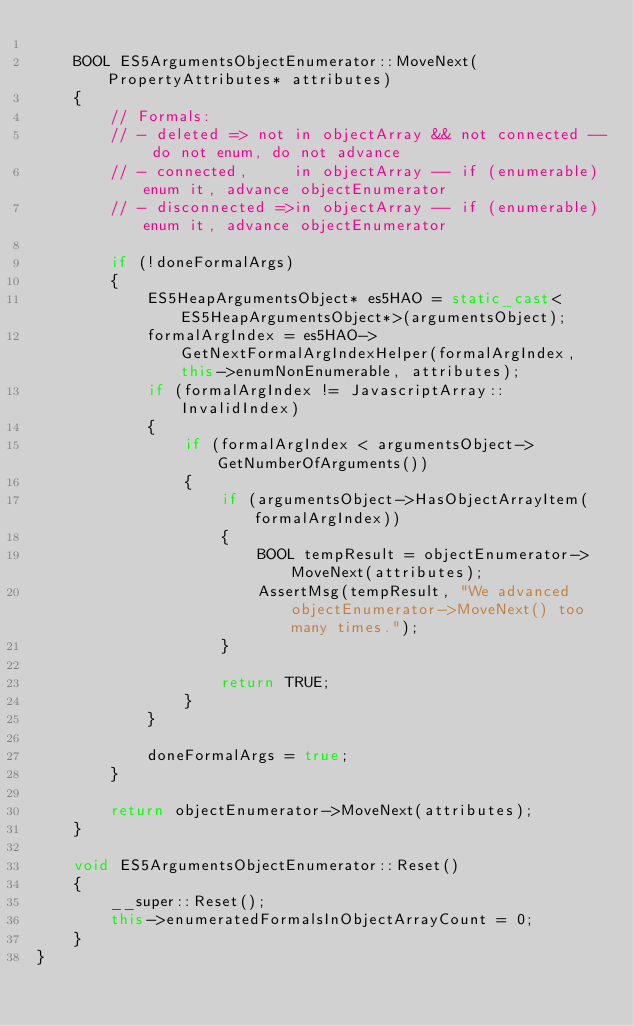Convert code to text. <code><loc_0><loc_0><loc_500><loc_500><_C++_>
    BOOL ES5ArgumentsObjectEnumerator::MoveNext(PropertyAttributes* attributes)
    {
        // Formals:
        // - deleted => not in objectArray && not connected -- do not enum, do not advance
        // - connected,     in objectArray -- if (enumerable) enum it, advance objectEnumerator
        // - disconnected =>in objectArray -- if (enumerable) enum it, advance objectEnumerator

        if (!doneFormalArgs)
        {
            ES5HeapArgumentsObject* es5HAO = static_cast<ES5HeapArgumentsObject*>(argumentsObject);
            formalArgIndex = es5HAO->GetNextFormalArgIndexHelper(formalArgIndex, this->enumNonEnumerable, attributes);
            if (formalArgIndex != JavascriptArray::InvalidIndex)
            {
                if (formalArgIndex < argumentsObject->GetNumberOfArguments())
                {
                    if (argumentsObject->HasObjectArrayItem(formalArgIndex))
                    {
                        BOOL tempResult = objectEnumerator->MoveNext(attributes);
                        AssertMsg(tempResult, "We advanced objectEnumerator->MoveNext() too many times.");
                    }

                    return TRUE;
                }
            }

            doneFormalArgs = true;
        }

        return objectEnumerator->MoveNext(attributes);
    }

    void ES5ArgumentsObjectEnumerator::Reset()
    {
        __super::Reset();
        this->enumeratedFormalsInObjectArrayCount = 0;
    }
}
</code> 